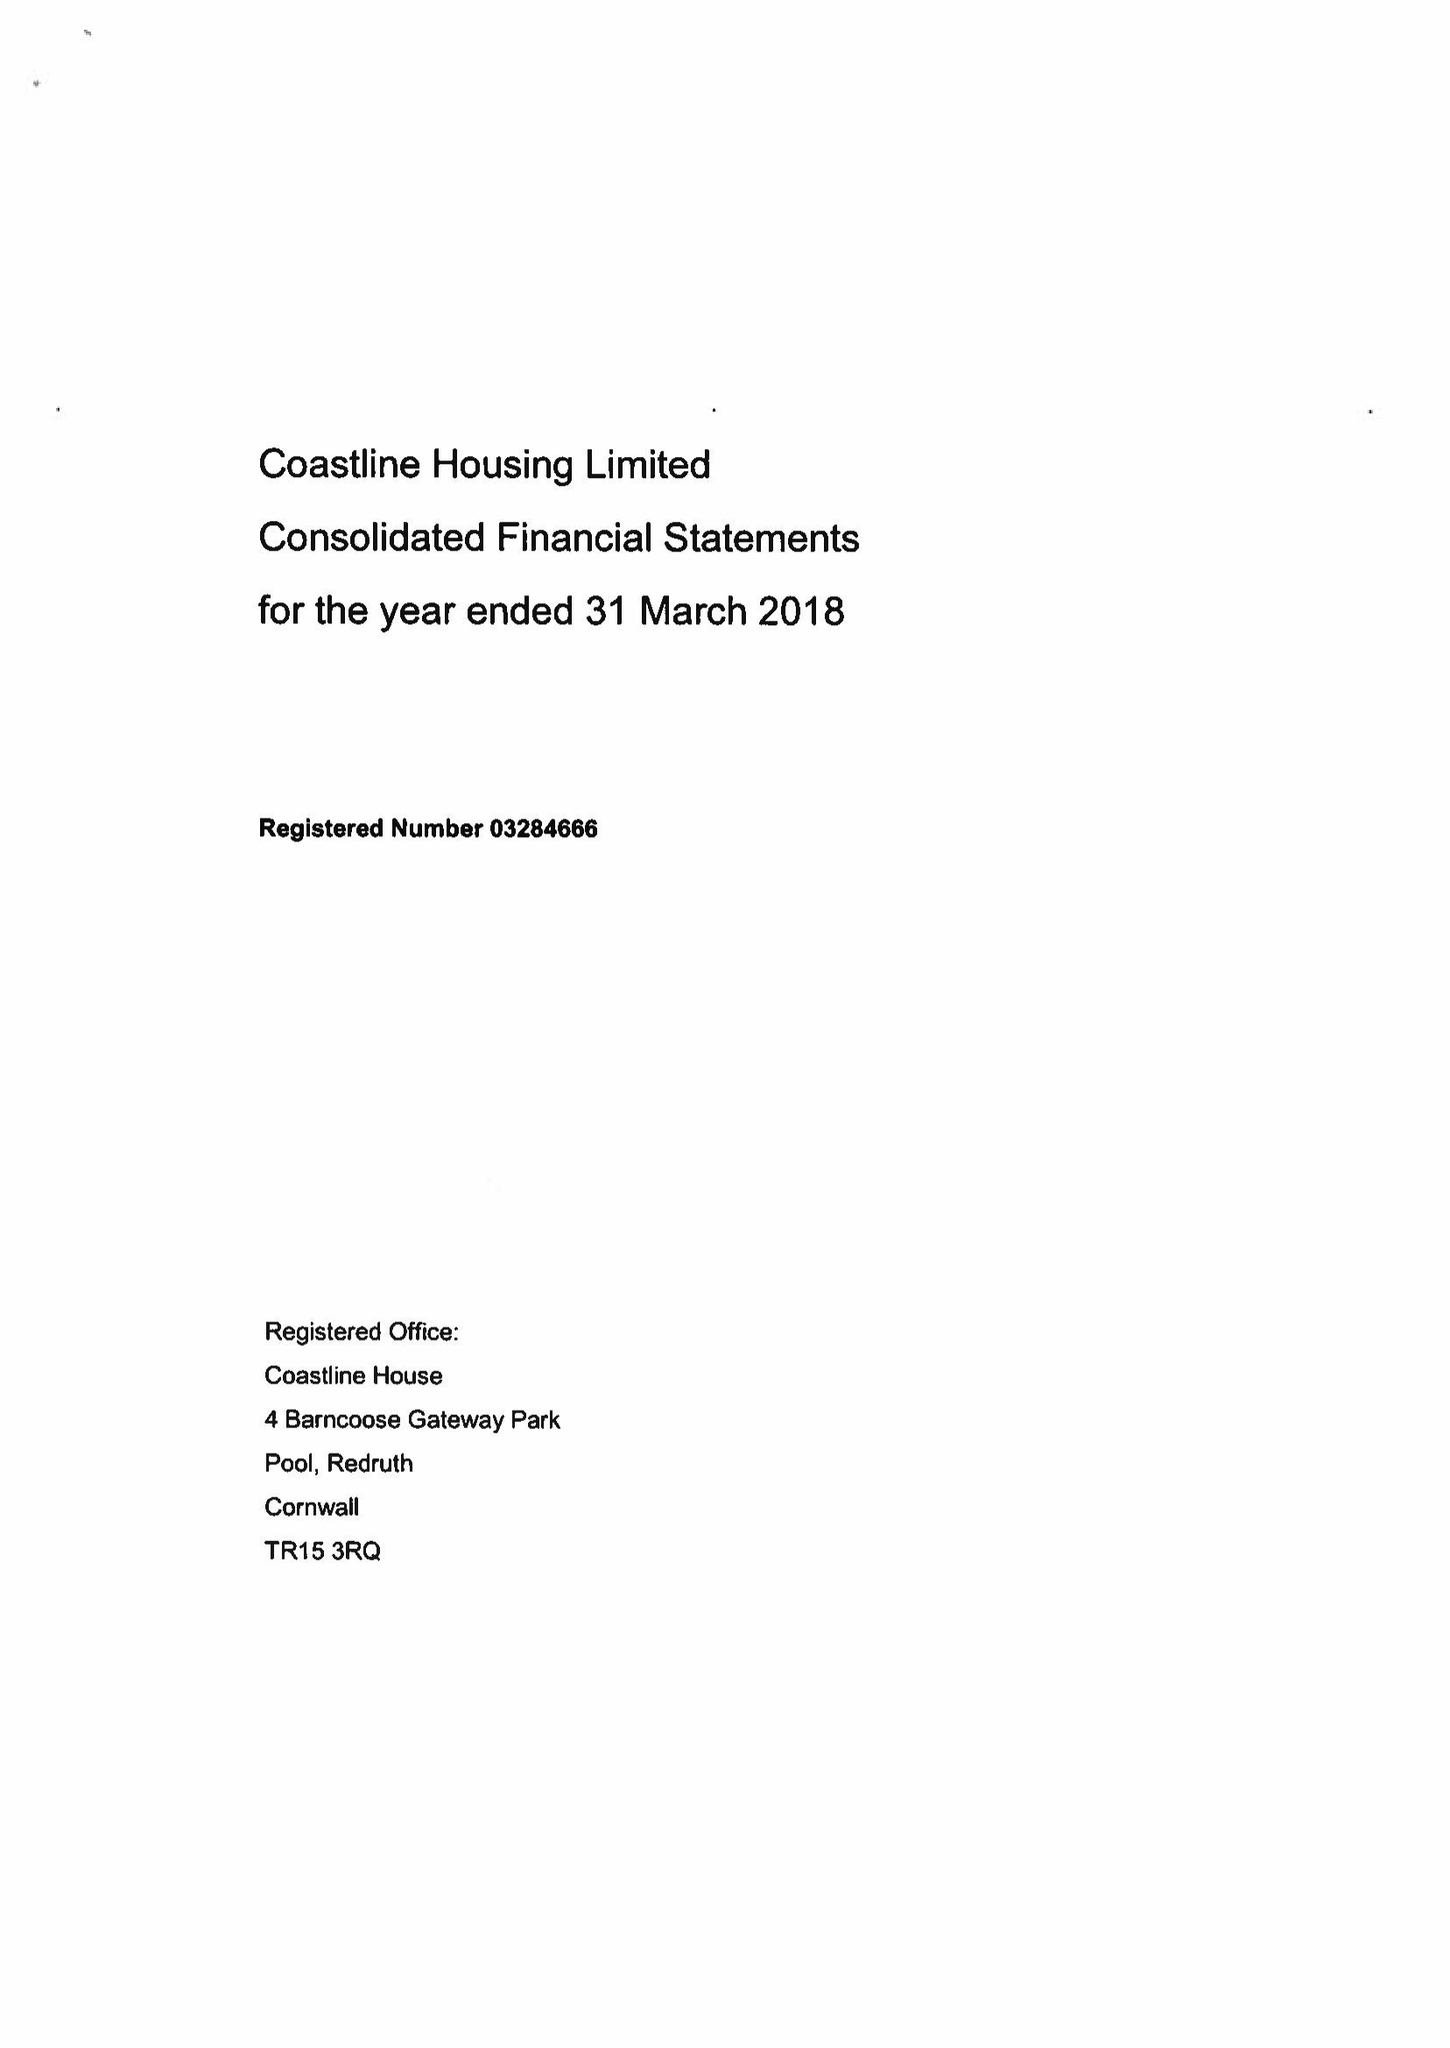What is the value for the address__street_line?
Answer the question using a single word or phrase. None 